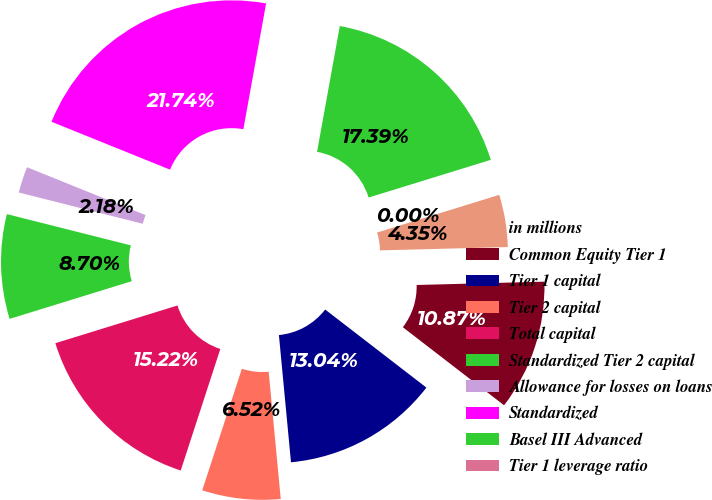<chart> <loc_0><loc_0><loc_500><loc_500><pie_chart><fcel>in millions<fcel>Common Equity Tier 1<fcel>Tier 1 capital<fcel>Tier 2 capital<fcel>Total capital<fcel>Standardized Tier 2 capital<fcel>Allowance for losses on loans<fcel>Standardized<fcel>Basel III Advanced<fcel>Tier 1 leverage ratio<nl><fcel>4.35%<fcel>10.87%<fcel>13.04%<fcel>6.52%<fcel>15.22%<fcel>8.7%<fcel>2.18%<fcel>21.74%<fcel>17.39%<fcel>0.0%<nl></chart> 